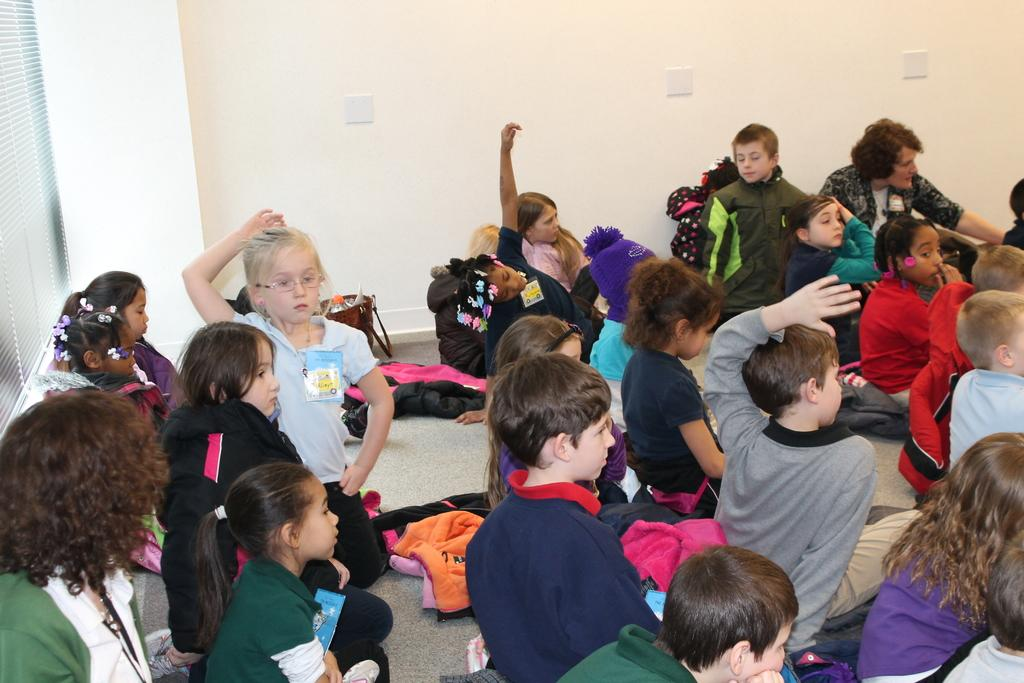What are the children in the image doing? The children in the image are sitting on the floor. Where is the window located in the image? The window is on the left side of the image. What color is the wall at the top of the image? The wall at the top of the image is white. What type of fang can be seen in the image? There is no fang present in the image. Is there a body of water visible in the image? No, there is no body of water visible in the image. 